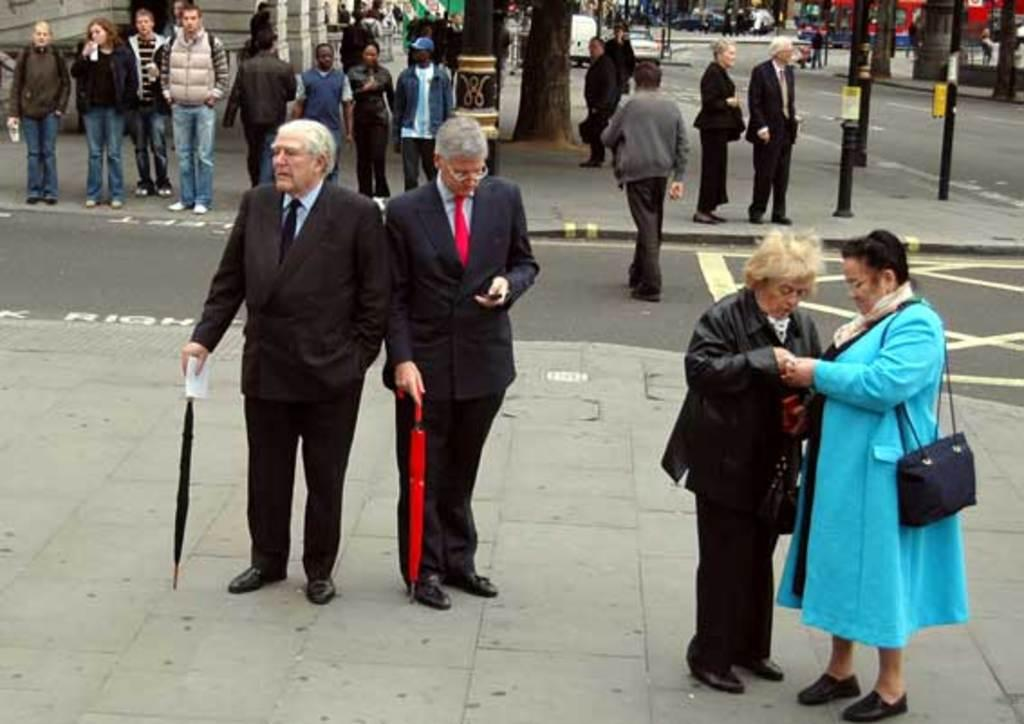How many people are standing on the left side of the image? There are two men standing on the left side of the image. What are the men wearing in the image? The men are wearing coats, trousers, ties, and shirts. What is the woman wearing in the image? The woman is wearing a blue sweater. What can be seen in the middle of the image? There is a road in the middle of the image. Can you see any goldfish swimming in the lake in the image? There is no lake or goldfish present in the image. 